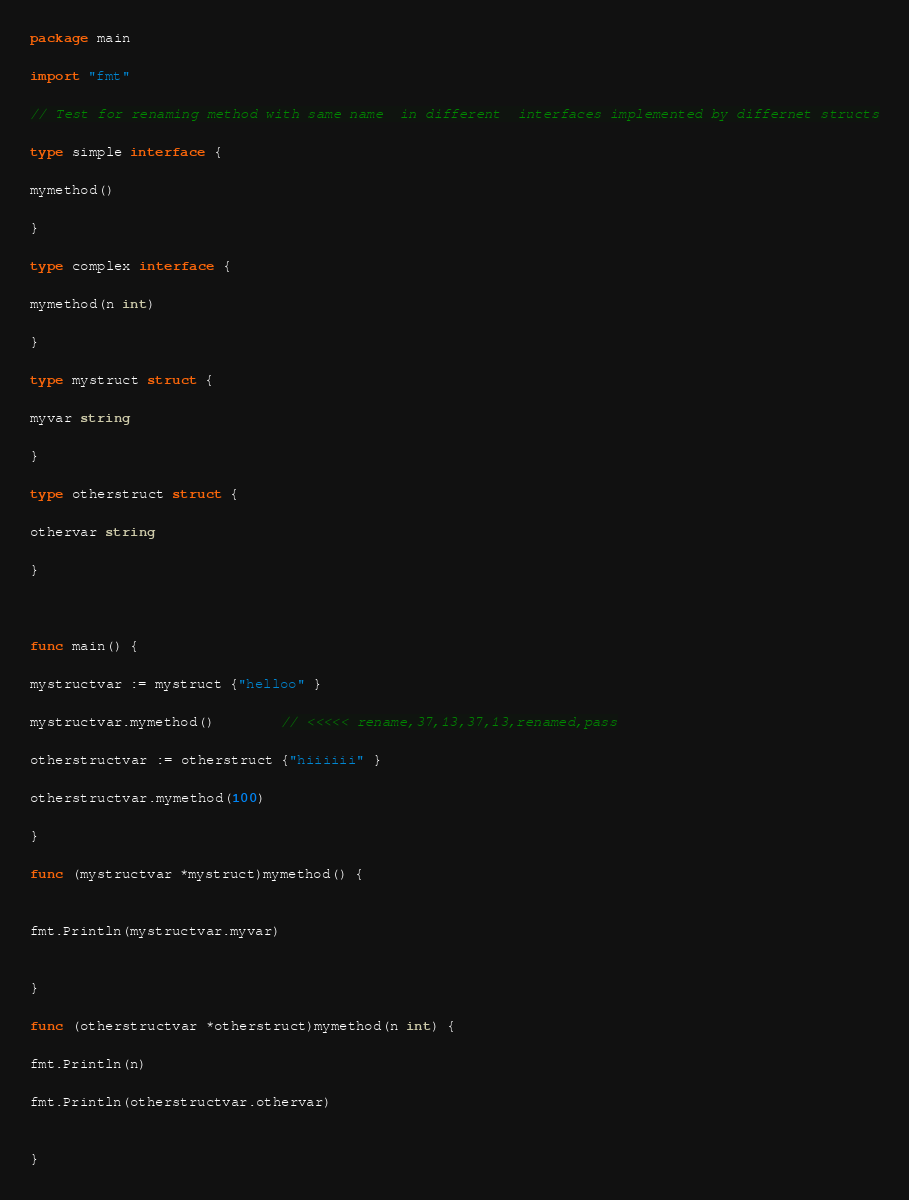<code> <loc_0><loc_0><loc_500><loc_500><_Go_>package main

import "fmt"

// Test for renaming method with same name  in different  interfaces implemented by differnet structs

type simple interface {

mymethod()

} 

type complex interface {

mymethod(n int)

}

type mystruct struct {

myvar string

}

type otherstruct struct {

othervar string

}



func main() {

mystructvar := mystruct {"helloo" }

mystructvar.mymethod()		// <<<<< rename,37,13,37,13,renamed,pass

otherstructvar := otherstruct {"hiiiiii" }

otherstructvar.mymethod(100)		

}

func (mystructvar *mystruct)mymethod() {


fmt.Println(mystructvar.myvar)


}

func (otherstructvar *otherstruct)mymethod(n int) {

fmt.Println(n)

fmt.Println(otherstructvar.othervar)


}

</code> 